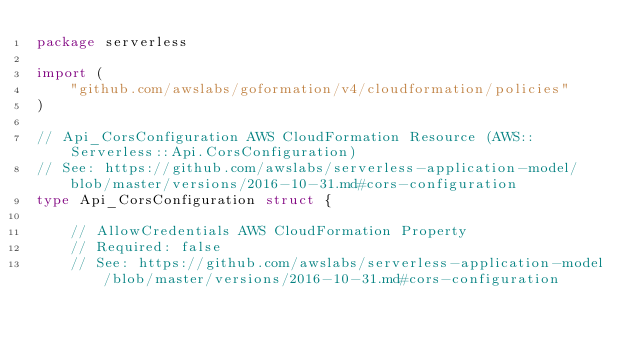<code> <loc_0><loc_0><loc_500><loc_500><_Go_>package serverless

import (
	"github.com/awslabs/goformation/v4/cloudformation/policies"
)

// Api_CorsConfiguration AWS CloudFormation Resource (AWS::Serverless::Api.CorsConfiguration)
// See: https://github.com/awslabs/serverless-application-model/blob/master/versions/2016-10-31.md#cors-configuration
type Api_CorsConfiguration struct {

	// AllowCredentials AWS CloudFormation Property
	// Required: false
	// See: https://github.com/awslabs/serverless-application-model/blob/master/versions/2016-10-31.md#cors-configuration</code> 